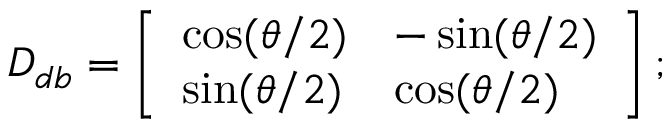<formula> <loc_0><loc_0><loc_500><loc_500>D _ { d b } = \left [ \begin{array} { l l } { \cos ( \theta / 2 ) } & { - \sin ( \theta / 2 ) } \\ { \sin ( \theta / 2 ) } & { \cos ( \theta / 2 ) } \end{array} \right ] ;</formula> 